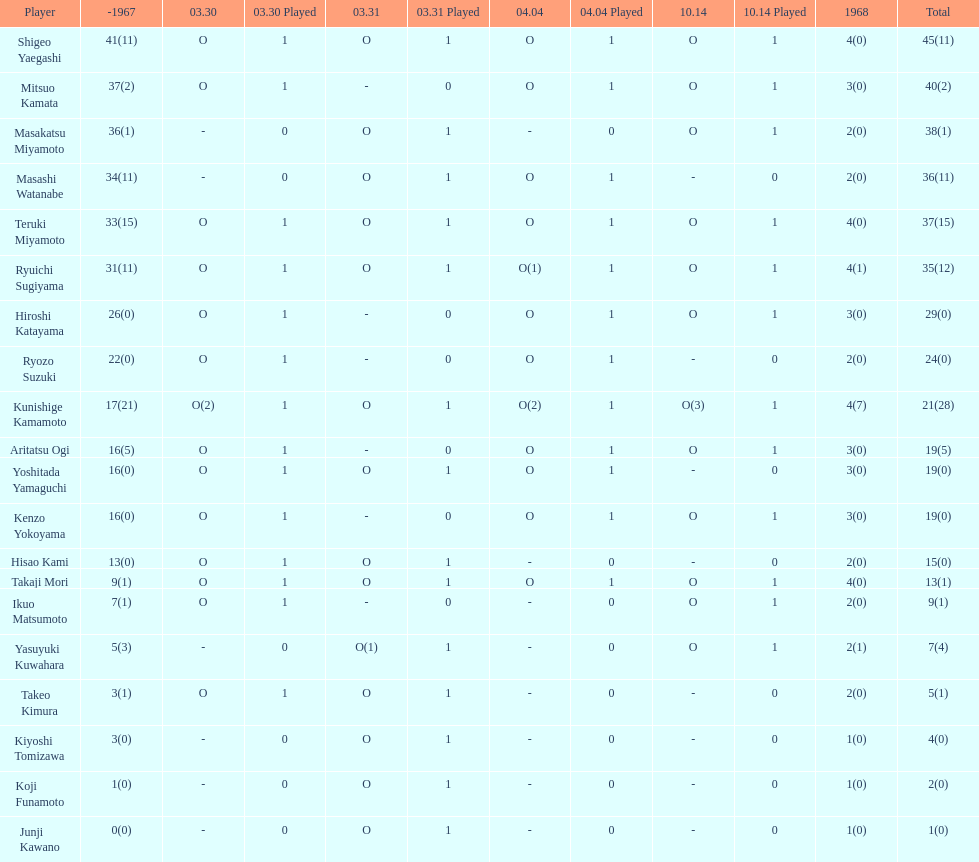Total appearances by masakatsu miyamoto? 38. 